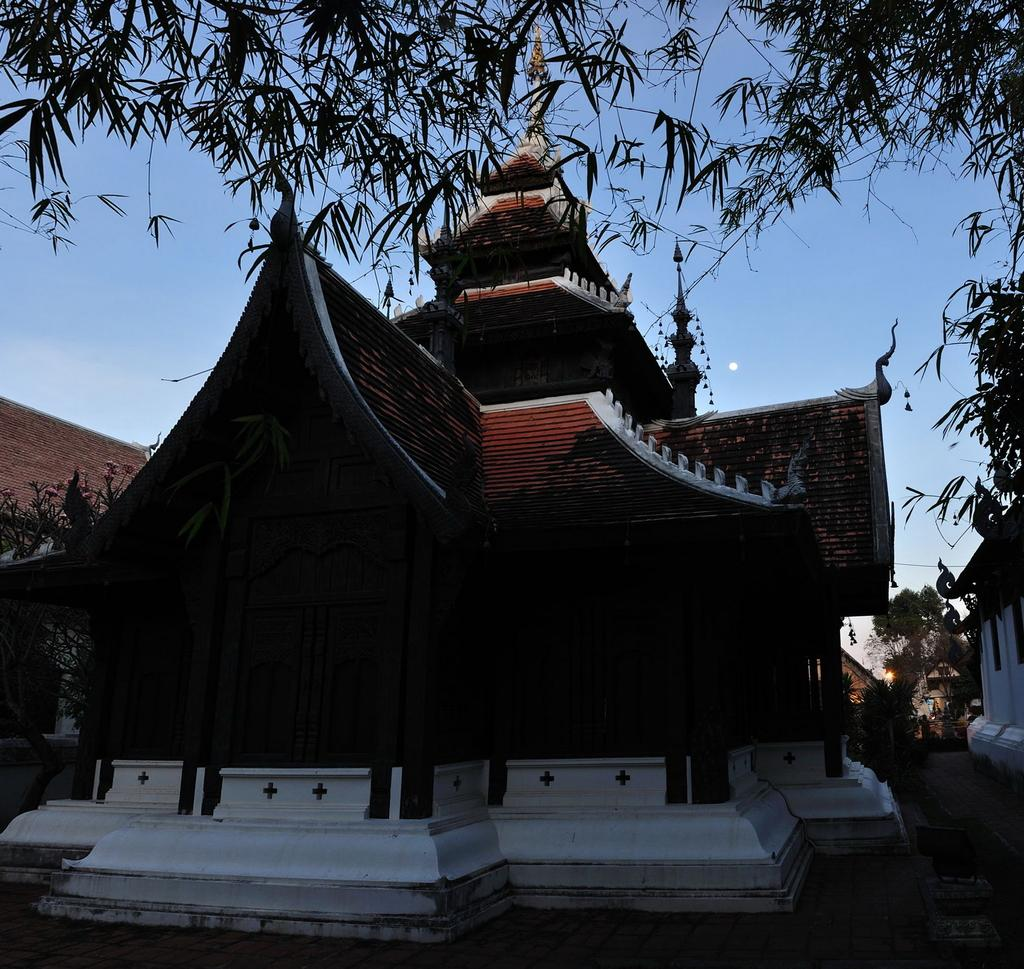What type of structure is present in the image? There is a building in the image. Can you describe the architectural style of the building? The building is constructed in Chinese style. What other elements can be seen in the image besides the building? There are trees in the image. What is visible in the background of the image? The sky is visible in the background of the image. Can you tell me how many friends are playing in the camp shown in the image? There is no camp or friends present in the image; it features a building in Chinese style with trees and a visible sky. 